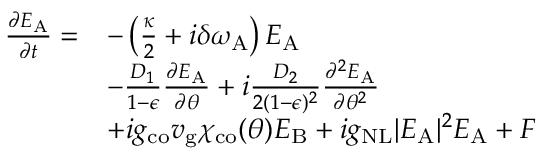<formula> <loc_0><loc_0><loc_500><loc_500>\begin{array} { r l } { \frac { \partial E _ { A } } { \partial t } = } & { - \left ( \frac { \kappa } { 2 } + i \delta \omega _ { A } \right ) E _ { A } } \\ & { - \frac { D _ { 1 } } { 1 - \epsilon } \frac { \partial E _ { A } } { \partial \theta } + i \frac { D _ { 2 } } { 2 ( 1 - \epsilon ) ^ { 2 } } \frac { \partial ^ { 2 } E _ { A } } { \partial \theta ^ { 2 } } } \\ & { + i g _ { c o } v _ { g } \chi _ { c o } ( \theta ) E _ { B } + i g _ { N L } | E _ { A } | ^ { 2 } E _ { A } + F } \end{array}</formula> 